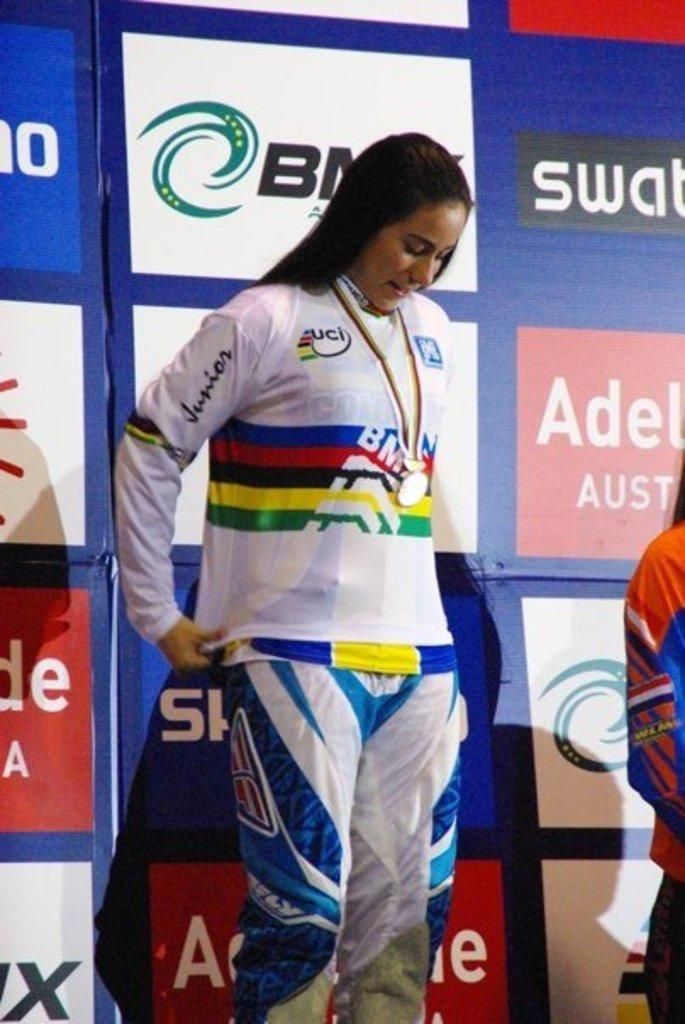<image>
Relay a brief, clear account of the picture shown. Athlete in a color uniform with Junior printed on the right arm in black. 